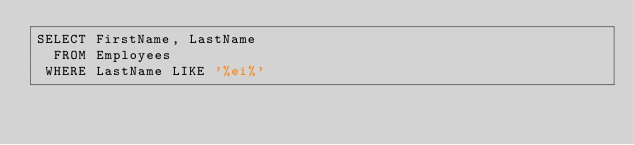Convert code to text. <code><loc_0><loc_0><loc_500><loc_500><_SQL_>SELECT FirstName, LastName 
  FROM Employees
 WHERE LastName LIKE '%ei%'</code> 